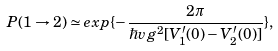<formula> <loc_0><loc_0><loc_500><loc_500>P ( 1 \rightarrow 2 ) \simeq e x p \{ - \frac { 2 \pi } { \hbar { v } g ^ { 2 } [ V _ { 1 } ^ { \prime } ( 0 ) - V _ { 2 } ^ { \prime } ( 0 ) ] } \} ,</formula> 